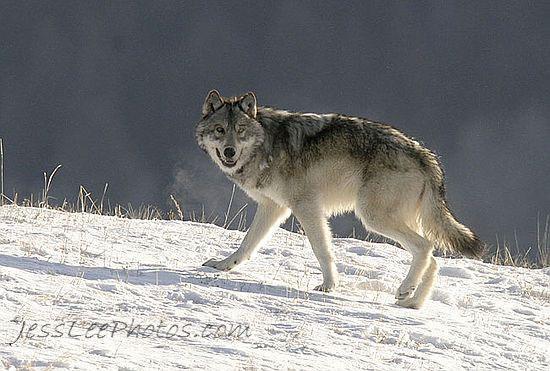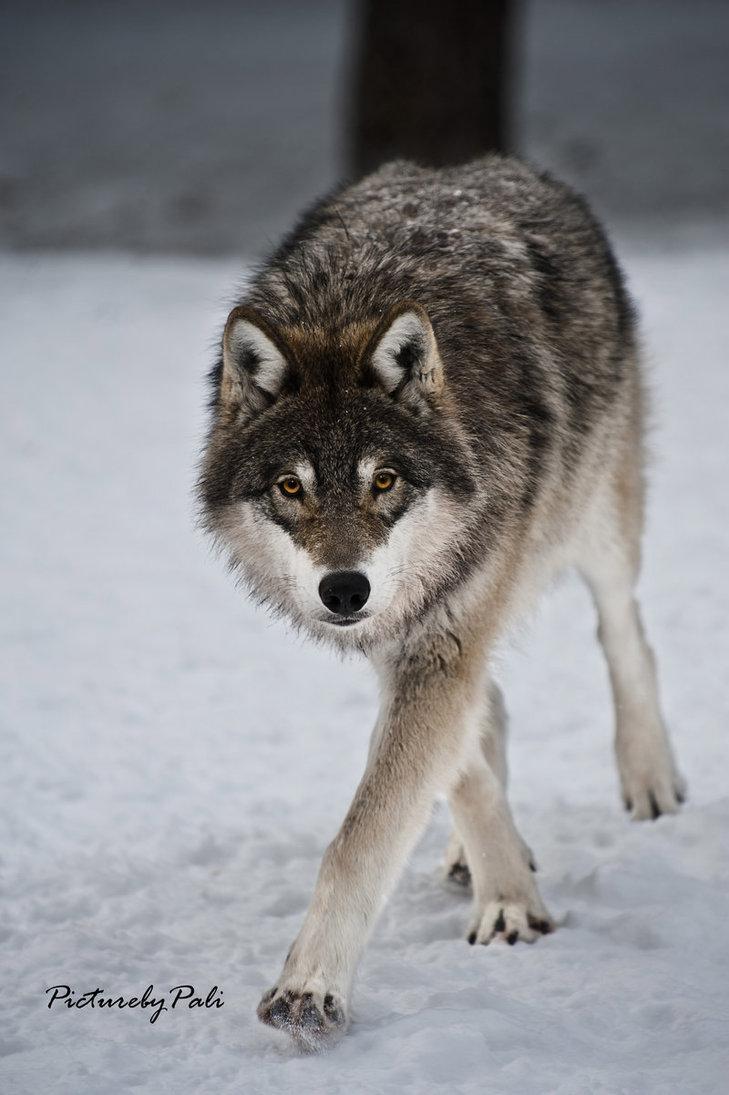The first image is the image on the left, the second image is the image on the right. Analyze the images presented: Is the assertion "in the left image there is a wold walking on snow covered ground with twigs sticking up through the snow" valid? Answer yes or no. Yes. 